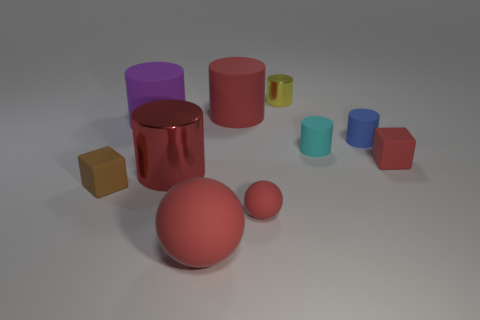Is there a blue rubber thing that is behind the red thing that is on the left side of the big red object in front of the big red metallic cylinder?
Make the answer very short. Yes. Is the material of the cube on the left side of the large red metal object the same as the blue object?
Ensure brevity in your answer.  Yes. The other thing that is the same shape as the small brown object is what color?
Provide a short and direct response. Red. Is the number of purple cylinders right of the small blue thing the same as the number of small cyan things?
Your answer should be compact. No. Are there any large purple rubber objects behind the purple rubber object?
Provide a succinct answer. No. How big is the matte cube right of the large red rubber thing that is in front of the red thing that is behind the large purple thing?
Offer a terse response. Small. There is a tiny rubber thing on the left side of the big sphere; does it have the same shape as the red thing that is on the right side of the blue cylinder?
Provide a succinct answer. Yes. What size is the red shiny thing that is the same shape as the tiny yellow thing?
Your response must be concise. Large. How many tiny cyan blocks have the same material as the tiny brown cube?
Your answer should be very brief. 0. What is the material of the purple object?
Give a very brief answer. Rubber. 